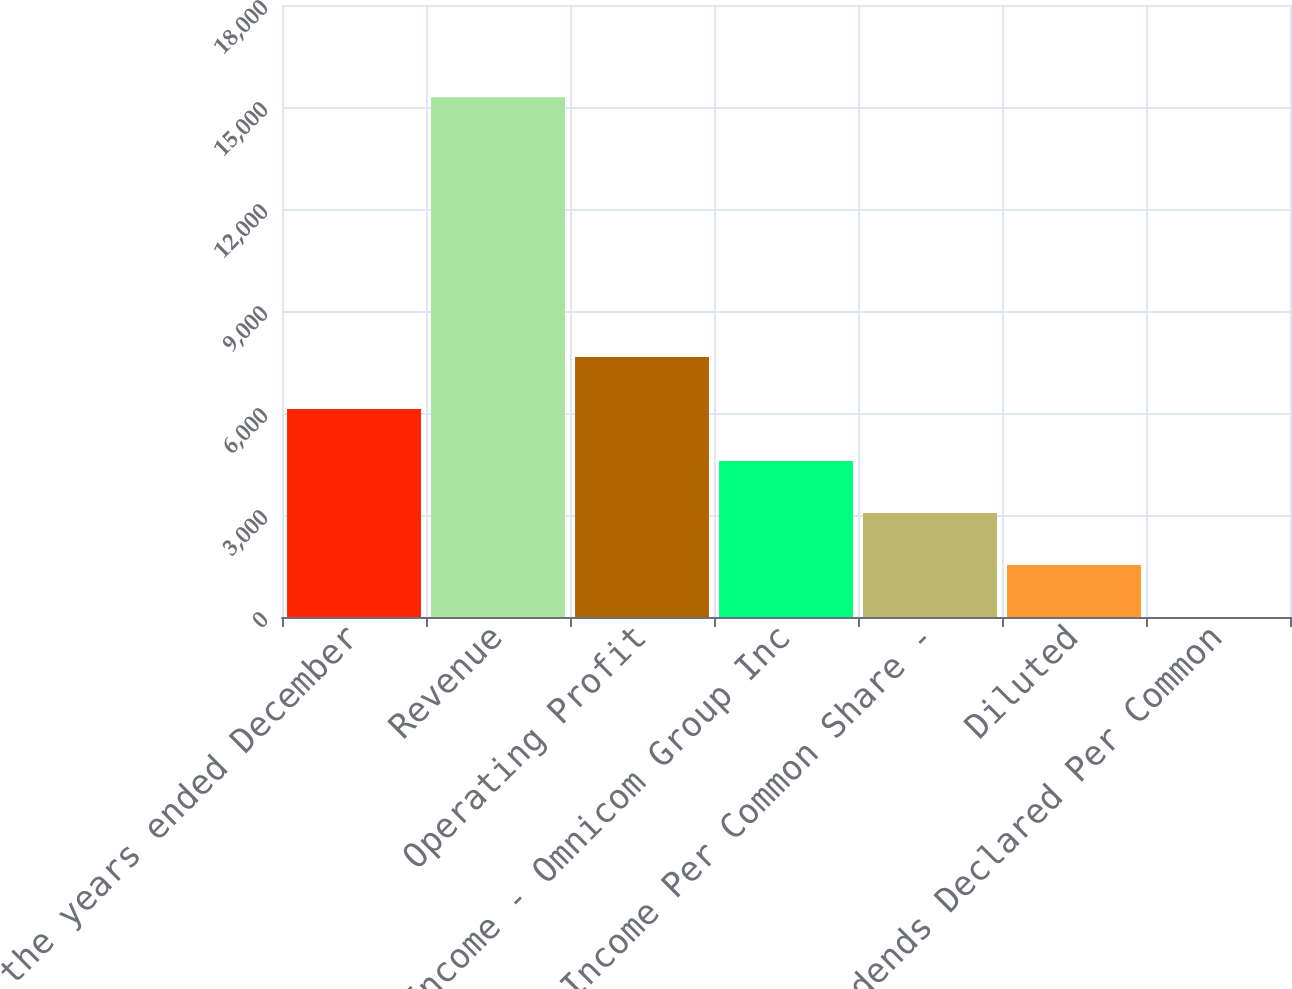Convert chart to OTSL. <chart><loc_0><loc_0><loc_500><loc_500><bar_chart><fcel>For the years ended December<fcel>Revenue<fcel>Operating Profit<fcel>Net Income - Omnicom Group Inc<fcel>Net Income Per Common Share -<fcel>Diluted<fcel>Dividends Declared Per Common<nl><fcel>6117.52<fcel>15290.2<fcel>7646.3<fcel>4588.74<fcel>3059.96<fcel>1531.18<fcel>2.4<nl></chart> 